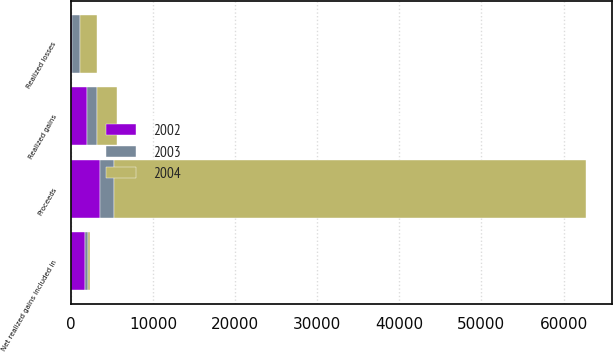<chart> <loc_0><loc_0><loc_500><loc_500><stacked_bar_chart><ecel><fcel>Proceeds<fcel>Realized gains<fcel>Realized losses<fcel>Net realized gains included in<nl><fcel>2003<fcel>1760<fcel>1289<fcel>900<fcel>384<nl><fcel>2004<fcel>57537<fcel>2371<fcel>2121<fcel>213<nl><fcel>2002<fcel>3499<fcel>1953<fcel>193<fcel>1760<nl></chart> 